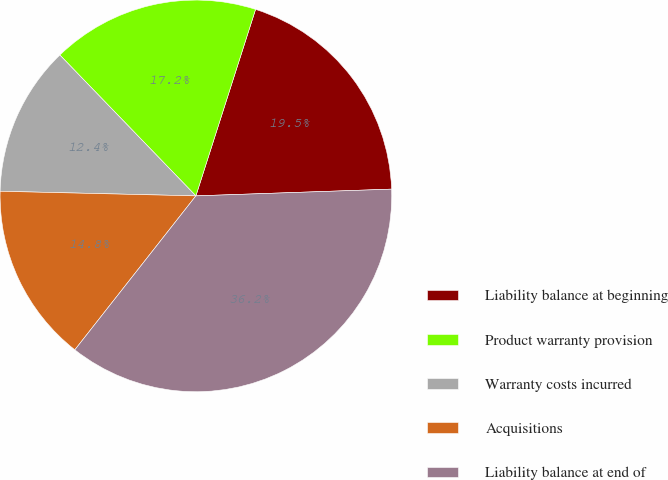Convert chart. <chart><loc_0><loc_0><loc_500><loc_500><pie_chart><fcel>Liability balance at beginning<fcel>Product warranty provision<fcel>Warranty costs incurred<fcel>Acquisitions<fcel>Liability balance at end of<nl><fcel>19.52%<fcel>17.15%<fcel>12.4%<fcel>14.77%<fcel>36.15%<nl></chart> 